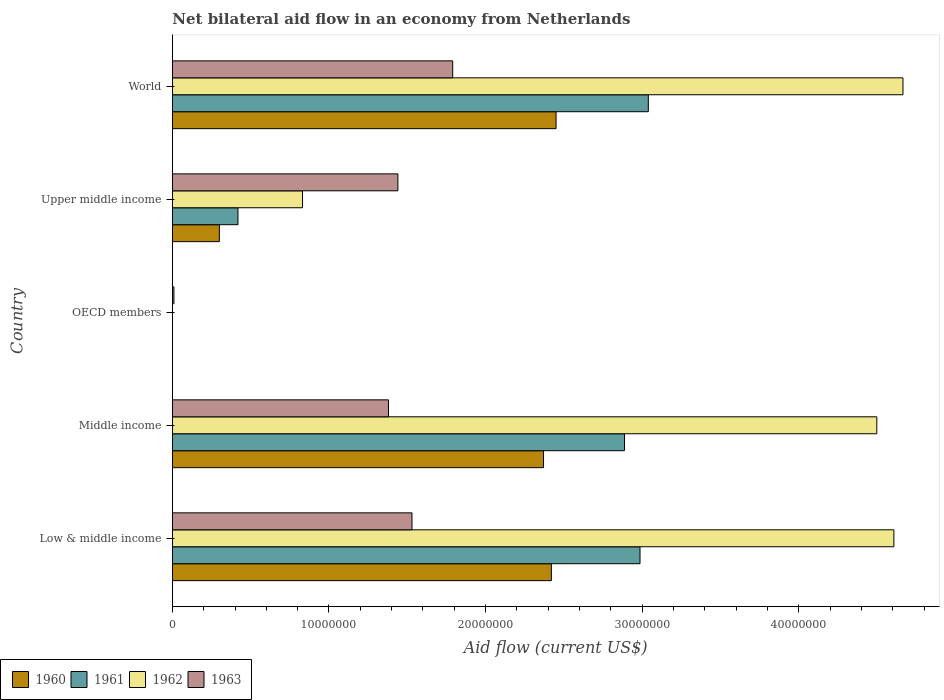How many different coloured bars are there?
Provide a short and direct response. 4. Are the number of bars per tick equal to the number of legend labels?
Offer a very short reply. No. What is the label of the 4th group of bars from the top?
Your answer should be very brief. Middle income. In how many cases, is the number of bars for a given country not equal to the number of legend labels?
Offer a very short reply. 1. What is the net bilateral aid flow in 1961 in Upper middle income?
Provide a succinct answer. 4.19e+06. Across all countries, what is the maximum net bilateral aid flow in 1963?
Give a very brief answer. 1.79e+07. In which country was the net bilateral aid flow in 1963 maximum?
Your answer should be compact. World. What is the total net bilateral aid flow in 1962 in the graph?
Provide a short and direct response. 1.46e+08. What is the difference between the net bilateral aid flow in 1961 in Low & middle income and that in Upper middle income?
Keep it short and to the point. 2.57e+07. What is the difference between the net bilateral aid flow in 1961 in OECD members and the net bilateral aid flow in 1960 in Low & middle income?
Provide a short and direct response. -2.42e+07. What is the average net bilateral aid flow in 1961 per country?
Ensure brevity in your answer.  1.87e+07. What is the difference between the net bilateral aid flow in 1961 and net bilateral aid flow in 1960 in Middle income?
Give a very brief answer. 5.17e+06. What is the ratio of the net bilateral aid flow in 1960 in Middle income to that in World?
Offer a terse response. 0.97. Is the difference between the net bilateral aid flow in 1961 in Upper middle income and World greater than the difference between the net bilateral aid flow in 1960 in Upper middle income and World?
Ensure brevity in your answer.  No. What is the difference between the highest and the second highest net bilateral aid flow in 1962?
Your response must be concise. 5.80e+05. What is the difference between the highest and the lowest net bilateral aid flow in 1961?
Keep it short and to the point. 3.04e+07. Is the sum of the net bilateral aid flow in 1961 in Middle income and World greater than the maximum net bilateral aid flow in 1963 across all countries?
Your answer should be compact. Yes. Is it the case that in every country, the sum of the net bilateral aid flow in 1962 and net bilateral aid flow in 1961 is greater than the net bilateral aid flow in 1963?
Your answer should be very brief. No. How many bars are there?
Keep it short and to the point. 17. Are all the bars in the graph horizontal?
Keep it short and to the point. Yes. How many countries are there in the graph?
Give a very brief answer. 5. What is the difference between two consecutive major ticks on the X-axis?
Provide a short and direct response. 1.00e+07. Does the graph contain grids?
Provide a succinct answer. No. Where does the legend appear in the graph?
Your answer should be compact. Bottom left. How many legend labels are there?
Provide a short and direct response. 4. How are the legend labels stacked?
Offer a terse response. Horizontal. What is the title of the graph?
Ensure brevity in your answer.  Net bilateral aid flow in an economy from Netherlands. Does "2008" appear as one of the legend labels in the graph?
Offer a terse response. No. What is the label or title of the Y-axis?
Provide a succinct answer. Country. What is the Aid flow (current US$) of 1960 in Low & middle income?
Your response must be concise. 2.42e+07. What is the Aid flow (current US$) in 1961 in Low & middle income?
Offer a very short reply. 2.99e+07. What is the Aid flow (current US$) in 1962 in Low & middle income?
Your answer should be compact. 4.61e+07. What is the Aid flow (current US$) in 1963 in Low & middle income?
Provide a short and direct response. 1.53e+07. What is the Aid flow (current US$) in 1960 in Middle income?
Offer a very short reply. 2.37e+07. What is the Aid flow (current US$) of 1961 in Middle income?
Your response must be concise. 2.89e+07. What is the Aid flow (current US$) in 1962 in Middle income?
Provide a short and direct response. 4.50e+07. What is the Aid flow (current US$) in 1963 in Middle income?
Your answer should be very brief. 1.38e+07. What is the Aid flow (current US$) of 1963 in OECD members?
Make the answer very short. 1.00e+05. What is the Aid flow (current US$) of 1961 in Upper middle income?
Provide a succinct answer. 4.19e+06. What is the Aid flow (current US$) in 1962 in Upper middle income?
Offer a terse response. 8.31e+06. What is the Aid flow (current US$) of 1963 in Upper middle income?
Your answer should be compact. 1.44e+07. What is the Aid flow (current US$) of 1960 in World?
Give a very brief answer. 2.45e+07. What is the Aid flow (current US$) in 1961 in World?
Offer a very short reply. 3.04e+07. What is the Aid flow (current US$) in 1962 in World?
Give a very brief answer. 4.66e+07. What is the Aid flow (current US$) of 1963 in World?
Your response must be concise. 1.79e+07. Across all countries, what is the maximum Aid flow (current US$) in 1960?
Your response must be concise. 2.45e+07. Across all countries, what is the maximum Aid flow (current US$) in 1961?
Your answer should be compact. 3.04e+07. Across all countries, what is the maximum Aid flow (current US$) in 1962?
Your response must be concise. 4.66e+07. Across all countries, what is the maximum Aid flow (current US$) in 1963?
Ensure brevity in your answer.  1.79e+07. Across all countries, what is the minimum Aid flow (current US$) in 1960?
Your answer should be compact. 0. Across all countries, what is the minimum Aid flow (current US$) of 1962?
Offer a very short reply. 0. What is the total Aid flow (current US$) of 1960 in the graph?
Give a very brief answer. 7.54e+07. What is the total Aid flow (current US$) of 1961 in the graph?
Your answer should be compact. 9.33e+07. What is the total Aid flow (current US$) of 1962 in the graph?
Provide a short and direct response. 1.46e+08. What is the total Aid flow (current US$) in 1963 in the graph?
Offer a terse response. 6.15e+07. What is the difference between the Aid flow (current US$) of 1960 in Low & middle income and that in Middle income?
Provide a short and direct response. 5.00e+05. What is the difference between the Aid flow (current US$) of 1961 in Low & middle income and that in Middle income?
Offer a terse response. 9.90e+05. What is the difference between the Aid flow (current US$) of 1962 in Low & middle income and that in Middle income?
Keep it short and to the point. 1.09e+06. What is the difference between the Aid flow (current US$) of 1963 in Low & middle income and that in Middle income?
Ensure brevity in your answer.  1.50e+06. What is the difference between the Aid flow (current US$) of 1963 in Low & middle income and that in OECD members?
Ensure brevity in your answer.  1.52e+07. What is the difference between the Aid flow (current US$) of 1960 in Low & middle income and that in Upper middle income?
Keep it short and to the point. 2.12e+07. What is the difference between the Aid flow (current US$) of 1961 in Low & middle income and that in Upper middle income?
Give a very brief answer. 2.57e+07. What is the difference between the Aid flow (current US$) of 1962 in Low & middle income and that in Upper middle income?
Your answer should be very brief. 3.78e+07. What is the difference between the Aid flow (current US$) in 1963 in Low & middle income and that in Upper middle income?
Your response must be concise. 9.00e+05. What is the difference between the Aid flow (current US$) in 1961 in Low & middle income and that in World?
Keep it short and to the point. -5.30e+05. What is the difference between the Aid flow (current US$) in 1962 in Low & middle income and that in World?
Give a very brief answer. -5.80e+05. What is the difference between the Aid flow (current US$) of 1963 in Low & middle income and that in World?
Your answer should be compact. -2.60e+06. What is the difference between the Aid flow (current US$) of 1963 in Middle income and that in OECD members?
Keep it short and to the point. 1.37e+07. What is the difference between the Aid flow (current US$) of 1960 in Middle income and that in Upper middle income?
Provide a short and direct response. 2.07e+07. What is the difference between the Aid flow (current US$) in 1961 in Middle income and that in Upper middle income?
Offer a very short reply. 2.47e+07. What is the difference between the Aid flow (current US$) in 1962 in Middle income and that in Upper middle income?
Make the answer very short. 3.67e+07. What is the difference between the Aid flow (current US$) of 1963 in Middle income and that in Upper middle income?
Your response must be concise. -6.00e+05. What is the difference between the Aid flow (current US$) in 1960 in Middle income and that in World?
Make the answer very short. -8.00e+05. What is the difference between the Aid flow (current US$) of 1961 in Middle income and that in World?
Keep it short and to the point. -1.52e+06. What is the difference between the Aid flow (current US$) of 1962 in Middle income and that in World?
Keep it short and to the point. -1.67e+06. What is the difference between the Aid flow (current US$) of 1963 in Middle income and that in World?
Your answer should be compact. -4.10e+06. What is the difference between the Aid flow (current US$) in 1963 in OECD members and that in Upper middle income?
Ensure brevity in your answer.  -1.43e+07. What is the difference between the Aid flow (current US$) in 1963 in OECD members and that in World?
Your answer should be compact. -1.78e+07. What is the difference between the Aid flow (current US$) in 1960 in Upper middle income and that in World?
Offer a terse response. -2.15e+07. What is the difference between the Aid flow (current US$) in 1961 in Upper middle income and that in World?
Your answer should be compact. -2.62e+07. What is the difference between the Aid flow (current US$) of 1962 in Upper middle income and that in World?
Keep it short and to the point. -3.83e+07. What is the difference between the Aid flow (current US$) in 1963 in Upper middle income and that in World?
Your response must be concise. -3.50e+06. What is the difference between the Aid flow (current US$) in 1960 in Low & middle income and the Aid flow (current US$) in 1961 in Middle income?
Offer a terse response. -4.67e+06. What is the difference between the Aid flow (current US$) of 1960 in Low & middle income and the Aid flow (current US$) of 1962 in Middle income?
Keep it short and to the point. -2.08e+07. What is the difference between the Aid flow (current US$) of 1960 in Low & middle income and the Aid flow (current US$) of 1963 in Middle income?
Keep it short and to the point. 1.04e+07. What is the difference between the Aid flow (current US$) in 1961 in Low & middle income and the Aid flow (current US$) in 1962 in Middle income?
Your answer should be very brief. -1.51e+07. What is the difference between the Aid flow (current US$) in 1961 in Low & middle income and the Aid flow (current US$) in 1963 in Middle income?
Offer a very short reply. 1.61e+07. What is the difference between the Aid flow (current US$) of 1962 in Low & middle income and the Aid flow (current US$) of 1963 in Middle income?
Provide a succinct answer. 3.23e+07. What is the difference between the Aid flow (current US$) in 1960 in Low & middle income and the Aid flow (current US$) in 1963 in OECD members?
Ensure brevity in your answer.  2.41e+07. What is the difference between the Aid flow (current US$) in 1961 in Low & middle income and the Aid flow (current US$) in 1963 in OECD members?
Provide a succinct answer. 2.98e+07. What is the difference between the Aid flow (current US$) in 1962 in Low & middle income and the Aid flow (current US$) in 1963 in OECD members?
Give a very brief answer. 4.60e+07. What is the difference between the Aid flow (current US$) in 1960 in Low & middle income and the Aid flow (current US$) in 1961 in Upper middle income?
Offer a terse response. 2.00e+07. What is the difference between the Aid flow (current US$) in 1960 in Low & middle income and the Aid flow (current US$) in 1962 in Upper middle income?
Your answer should be compact. 1.59e+07. What is the difference between the Aid flow (current US$) of 1960 in Low & middle income and the Aid flow (current US$) of 1963 in Upper middle income?
Offer a very short reply. 9.80e+06. What is the difference between the Aid flow (current US$) of 1961 in Low & middle income and the Aid flow (current US$) of 1962 in Upper middle income?
Provide a succinct answer. 2.16e+07. What is the difference between the Aid flow (current US$) in 1961 in Low & middle income and the Aid flow (current US$) in 1963 in Upper middle income?
Offer a terse response. 1.55e+07. What is the difference between the Aid flow (current US$) in 1962 in Low & middle income and the Aid flow (current US$) in 1963 in Upper middle income?
Offer a very short reply. 3.17e+07. What is the difference between the Aid flow (current US$) in 1960 in Low & middle income and the Aid flow (current US$) in 1961 in World?
Keep it short and to the point. -6.19e+06. What is the difference between the Aid flow (current US$) of 1960 in Low & middle income and the Aid flow (current US$) of 1962 in World?
Offer a very short reply. -2.24e+07. What is the difference between the Aid flow (current US$) of 1960 in Low & middle income and the Aid flow (current US$) of 1963 in World?
Your answer should be very brief. 6.30e+06. What is the difference between the Aid flow (current US$) in 1961 in Low & middle income and the Aid flow (current US$) in 1962 in World?
Offer a very short reply. -1.68e+07. What is the difference between the Aid flow (current US$) in 1961 in Low & middle income and the Aid flow (current US$) in 1963 in World?
Keep it short and to the point. 1.20e+07. What is the difference between the Aid flow (current US$) in 1962 in Low & middle income and the Aid flow (current US$) in 1963 in World?
Make the answer very short. 2.82e+07. What is the difference between the Aid flow (current US$) in 1960 in Middle income and the Aid flow (current US$) in 1963 in OECD members?
Offer a very short reply. 2.36e+07. What is the difference between the Aid flow (current US$) in 1961 in Middle income and the Aid flow (current US$) in 1963 in OECD members?
Your answer should be compact. 2.88e+07. What is the difference between the Aid flow (current US$) in 1962 in Middle income and the Aid flow (current US$) in 1963 in OECD members?
Provide a short and direct response. 4.49e+07. What is the difference between the Aid flow (current US$) of 1960 in Middle income and the Aid flow (current US$) of 1961 in Upper middle income?
Your answer should be very brief. 1.95e+07. What is the difference between the Aid flow (current US$) in 1960 in Middle income and the Aid flow (current US$) in 1962 in Upper middle income?
Provide a short and direct response. 1.54e+07. What is the difference between the Aid flow (current US$) of 1960 in Middle income and the Aid flow (current US$) of 1963 in Upper middle income?
Offer a very short reply. 9.30e+06. What is the difference between the Aid flow (current US$) of 1961 in Middle income and the Aid flow (current US$) of 1962 in Upper middle income?
Keep it short and to the point. 2.06e+07. What is the difference between the Aid flow (current US$) of 1961 in Middle income and the Aid flow (current US$) of 1963 in Upper middle income?
Offer a terse response. 1.45e+07. What is the difference between the Aid flow (current US$) of 1962 in Middle income and the Aid flow (current US$) of 1963 in Upper middle income?
Make the answer very short. 3.06e+07. What is the difference between the Aid flow (current US$) of 1960 in Middle income and the Aid flow (current US$) of 1961 in World?
Keep it short and to the point. -6.69e+06. What is the difference between the Aid flow (current US$) of 1960 in Middle income and the Aid flow (current US$) of 1962 in World?
Your answer should be very brief. -2.30e+07. What is the difference between the Aid flow (current US$) of 1960 in Middle income and the Aid flow (current US$) of 1963 in World?
Your answer should be very brief. 5.80e+06. What is the difference between the Aid flow (current US$) of 1961 in Middle income and the Aid flow (current US$) of 1962 in World?
Offer a terse response. -1.78e+07. What is the difference between the Aid flow (current US$) of 1961 in Middle income and the Aid flow (current US$) of 1963 in World?
Provide a short and direct response. 1.10e+07. What is the difference between the Aid flow (current US$) of 1962 in Middle income and the Aid flow (current US$) of 1963 in World?
Your answer should be compact. 2.71e+07. What is the difference between the Aid flow (current US$) of 1960 in Upper middle income and the Aid flow (current US$) of 1961 in World?
Make the answer very short. -2.74e+07. What is the difference between the Aid flow (current US$) in 1960 in Upper middle income and the Aid flow (current US$) in 1962 in World?
Your answer should be very brief. -4.36e+07. What is the difference between the Aid flow (current US$) of 1960 in Upper middle income and the Aid flow (current US$) of 1963 in World?
Offer a very short reply. -1.49e+07. What is the difference between the Aid flow (current US$) of 1961 in Upper middle income and the Aid flow (current US$) of 1962 in World?
Ensure brevity in your answer.  -4.25e+07. What is the difference between the Aid flow (current US$) in 1961 in Upper middle income and the Aid flow (current US$) in 1963 in World?
Your answer should be compact. -1.37e+07. What is the difference between the Aid flow (current US$) in 1962 in Upper middle income and the Aid flow (current US$) in 1963 in World?
Offer a terse response. -9.59e+06. What is the average Aid flow (current US$) of 1960 per country?
Ensure brevity in your answer.  1.51e+07. What is the average Aid flow (current US$) of 1961 per country?
Offer a terse response. 1.87e+07. What is the average Aid flow (current US$) of 1962 per country?
Keep it short and to the point. 2.92e+07. What is the average Aid flow (current US$) of 1963 per country?
Give a very brief answer. 1.23e+07. What is the difference between the Aid flow (current US$) of 1960 and Aid flow (current US$) of 1961 in Low & middle income?
Provide a succinct answer. -5.66e+06. What is the difference between the Aid flow (current US$) of 1960 and Aid flow (current US$) of 1962 in Low & middle income?
Your answer should be compact. -2.19e+07. What is the difference between the Aid flow (current US$) of 1960 and Aid flow (current US$) of 1963 in Low & middle income?
Your answer should be very brief. 8.90e+06. What is the difference between the Aid flow (current US$) of 1961 and Aid flow (current US$) of 1962 in Low & middle income?
Your answer should be compact. -1.62e+07. What is the difference between the Aid flow (current US$) of 1961 and Aid flow (current US$) of 1963 in Low & middle income?
Keep it short and to the point. 1.46e+07. What is the difference between the Aid flow (current US$) in 1962 and Aid flow (current US$) in 1963 in Low & middle income?
Provide a short and direct response. 3.08e+07. What is the difference between the Aid flow (current US$) in 1960 and Aid flow (current US$) in 1961 in Middle income?
Offer a terse response. -5.17e+06. What is the difference between the Aid flow (current US$) in 1960 and Aid flow (current US$) in 1962 in Middle income?
Provide a short and direct response. -2.13e+07. What is the difference between the Aid flow (current US$) of 1960 and Aid flow (current US$) of 1963 in Middle income?
Your answer should be very brief. 9.90e+06. What is the difference between the Aid flow (current US$) of 1961 and Aid flow (current US$) of 1962 in Middle income?
Your response must be concise. -1.61e+07. What is the difference between the Aid flow (current US$) of 1961 and Aid flow (current US$) of 1963 in Middle income?
Offer a terse response. 1.51e+07. What is the difference between the Aid flow (current US$) in 1962 and Aid flow (current US$) in 1963 in Middle income?
Your answer should be compact. 3.12e+07. What is the difference between the Aid flow (current US$) of 1960 and Aid flow (current US$) of 1961 in Upper middle income?
Provide a short and direct response. -1.19e+06. What is the difference between the Aid flow (current US$) in 1960 and Aid flow (current US$) in 1962 in Upper middle income?
Give a very brief answer. -5.31e+06. What is the difference between the Aid flow (current US$) of 1960 and Aid flow (current US$) of 1963 in Upper middle income?
Provide a short and direct response. -1.14e+07. What is the difference between the Aid flow (current US$) of 1961 and Aid flow (current US$) of 1962 in Upper middle income?
Your response must be concise. -4.12e+06. What is the difference between the Aid flow (current US$) in 1961 and Aid flow (current US$) in 1963 in Upper middle income?
Make the answer very short. -1.02e+07. What is the difference between the Aid flow (current US$) of 1962 and Aid flow (current US$) of 1963 in Upper middle income?
Offer a terse response. -6.09e+06. What is the difference between the Aid flow (current US$) of 1960 and Aid flow (current US$) of 1961 in World?
Offer a very short reply. -5.89e+06. What is the difference between the Aid flow (current US$) in 1960 and Aid flow (current US$) in 1962 in World?
Make the answer very short. -2.22e+07. What is the difference between the Aid flow (current US$) of 1960 and Aid flow (current US$) of 1963 in World?
Your answer should be compact. 6.60e+06. What is the difference between the Aid flow (current US$) in 1961 and Aid flow (current US$) in 1962 in World?
Give a very brief answer. -1.63e+07. What is the difference between the Aid flow (current US$) of 1961 and Aid flow (current US$) of 1963 in World?
Your response must be concise. 1.25e+07. What is the difference between the Aid flow (current US$) of 1962 and Aid flow (current US$) of 1963 in World?
Your response must be concise. 2.88e+07. What is the ratio of the Aid flow (current US$) of 1960 in Low & middle income to that in Middle income?
Give a very brief answer. 1.02. What is the ratio of the Aid flow (current US$) in 1961 in Low & middle income to that in Middle income?
Provide a short and direct response. 1.03. What is the ratio of the Aid flow (current US$) in 1962 in Low & middle income to that in Middle income?
Make the answer very short. 1.02. What is the ratio of the Aid flow (current US$) in 1963 in Low & middle income to that in Middle income?
Ensure brevity in your answer.  1.11. What is the ratio of the Aid flow (current US$) of 1963 in Low & middle income to that in OECD members?
Provide a succinct answer. 153. What is the ratio of the Aid flow (current US$) in 1960 in Low & middle income to that in Upper middle income?
Your response must be concise. 8.07. What is the ratio of the Aid flow (current US$) in 1961 in Low & middle income to that in Upper middle income?
Provide a short and direct response. 7.13. What is the ratio of the Aid flow (current US$) of 1962 in Low & middle income to that in Upper middle income?
Your response must be concise. 5.54. What is the ratio of the Aid flow (current US$) of 1963 in Low & middle income to that in Upper middle income?
Make the answer very short. 1.06. What is the ratio of the Aid flow (current US$) in 1961 in Low & middle income to that in World?
Your answer should be compact. 0.98. What is the ratio of the Aid flow (current US$) of 1962 in Low & middle income to that in World?
Make the answer very short. 0.99. What is the ratio of the Aid flow (current US$) of 1963 in Low & middle income to that in World?
Your response must be concise. 0.85. What is the ratio of the Aid flow (current US$) of 1963 in Middle income to that in OECD members?
Your answer should be compact. 138. What is the ratio of the Aid flow (current US$) in 1961 in Middle income to that in Upper middle income?
Your answer should be very brief. 6.89. What is the ratio of the Aid flow (current US$) in 1962 in Middle income to that in Upper middle income?
Ensure brevity in your answer.  5.41. What is the ratio of the Aid flow (current US$) of 1960 in Middle income to that in World?
Your response must be concise. 0.97. What is the ratio of the Aid flow (current US$) in 1962 in Middle income to that in World?
Provide a short and direct response. 0.96. What is the ratio of the Aid flow (current US$) of 1963 in Middle income to that in World?
Offer a very short reply. 0.77. What is the ratio of the Aid flow (current US$) of 1963 in OECD members to that in Upper middle income?
Ensure brevity in your answer.  0.01. What is the ratio of the Aid flow (current US$) of 1963 in OECD members to that in World?
Give a very brief answer. 0.01. What is the ratio of the Aid flow (current US$) of 1960 in Upper middle income to that in World?
Your answer should be compact. 0.12. What is the ratio of the Aid flow (current US$) in 1961 in Upper middle income to that in World?
Make the answer very short. 0.14. What is the ratio of the Aid flow (current US$) in 1962 in Upper middle income to that in World?
Provide a short and direct response. 0.18. What is the ratio of the Aid flow (current US$) of 1963 in Upper middle income to that in World?
Provide a short and direct response. 0.8. What is the difference between the highest and the second highest Aid flow (current US$) of 1961?
Keep it short and to the point. 5.30e+05. What is the difference between the highest and the second highest Aid flow (current US$) in 1962?
Provide a succinct answer. 5.80e+05. What is the difference between the highest and the second highest Aid flow (current US$) of 1963?
Offer a terse response. 2.60e+06. What is the difference between the highest and the lowest Aid flow (current US$) of 1960?
Keep it short and to the point. 2.45e+07. What is the difference between the highest and the lowest Aid flow (current US$) of 1961?
Ensure brevity in your answer.  3.04e+07. What is the difference between the highest and the lowest Aid flow (current US$) of 1962?
Give a very brief answer. 4.66e+07. What is the difference between the highest and the lowest Aid flow (current US$) in 1963?
Offer a very short reply. 1.78e+07. 